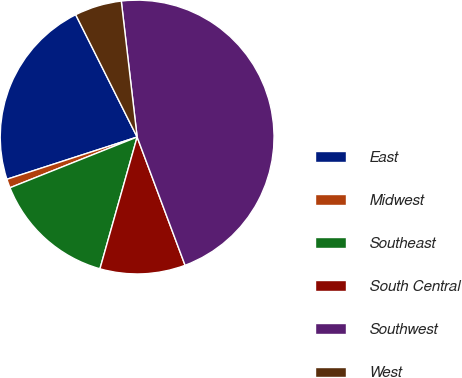Convert chart to OTSL. <chart><loc_0><loc_0><loc_500><loc_500><pie_chart><fcel>East<fcel>Midwest<fcel>Southeast<fcel>South Central<fcel>Southwest<fcel>West<nl><fcel>22.58%<fcel>1.05%<fcel>14.58%<fcel>10.07%<fcel>46.15%<fcel>5.56%<nl></chart> 